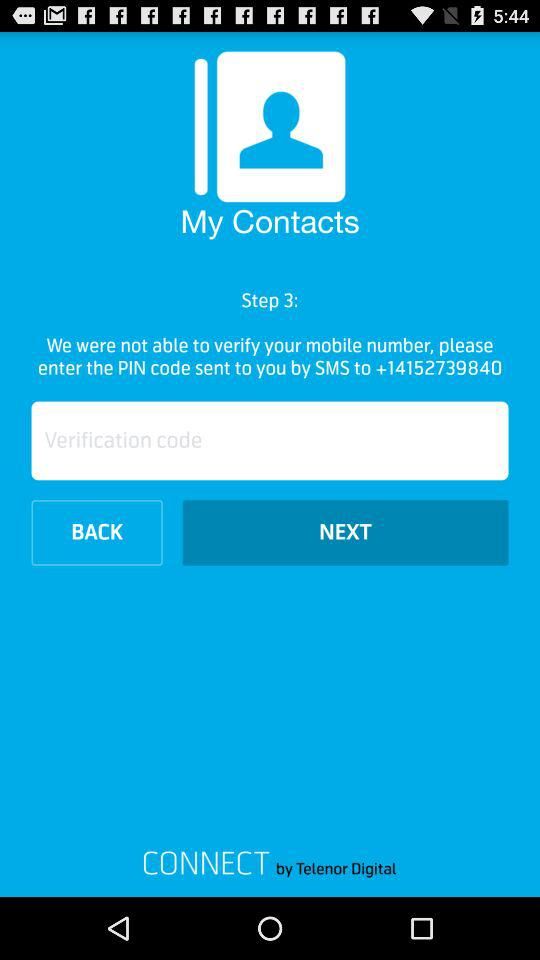What steps are displayed on the screen? The step displayed on the screen is 3. 